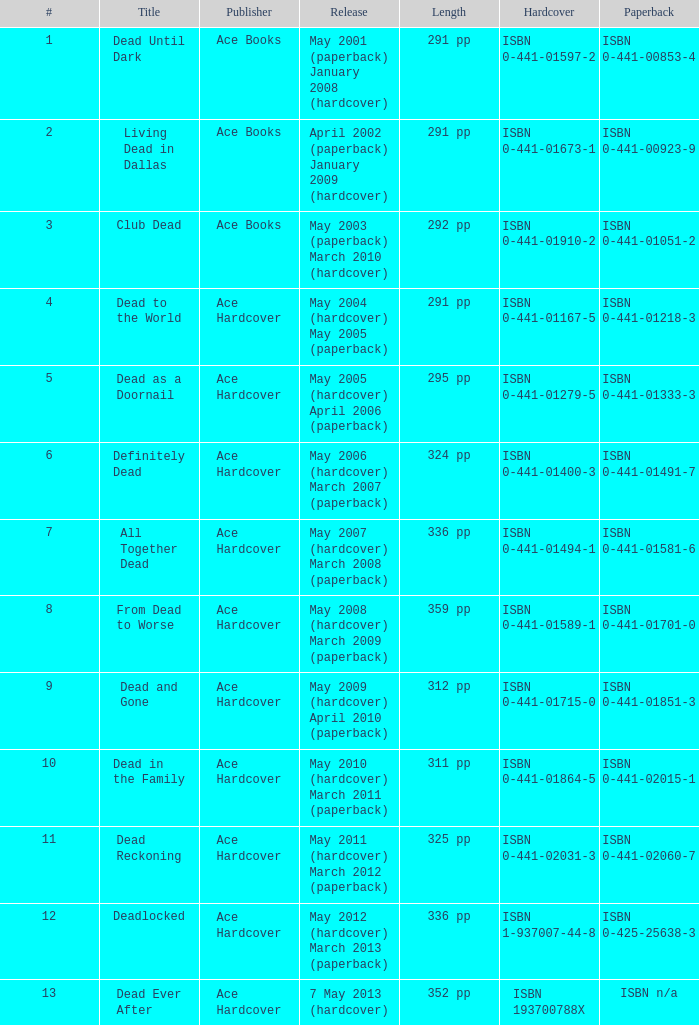What is the ISBN of "Dead as a Doornail? ISBN 0-441-01333-3. 